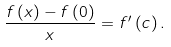Convert formula to latex. <formula><loc_0><loc_0><loc_500><loc_500>\frac { f \left ( x \right ) - f \left ( 0 \right ) } { x } = f ^ { \prime } \left ( c \right ) .</formula> 